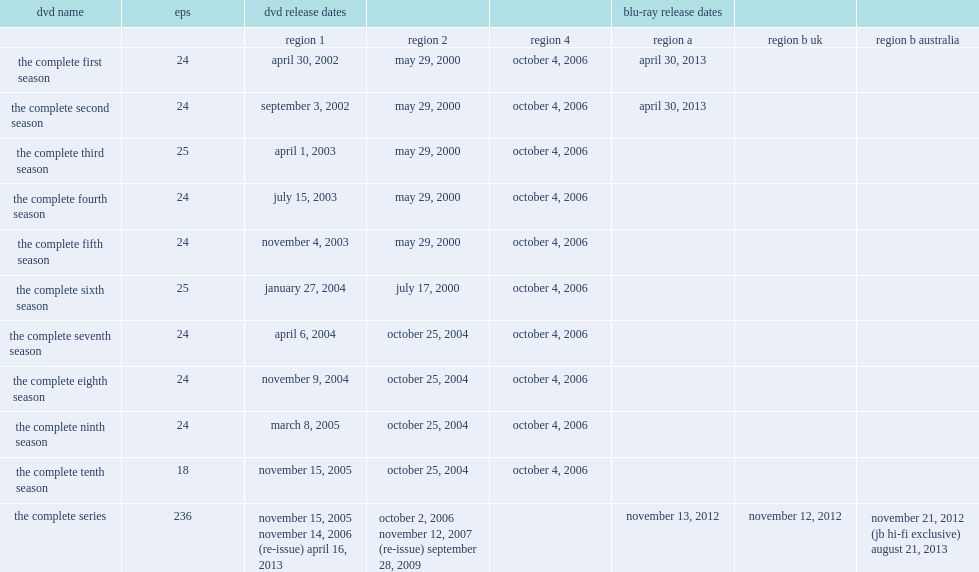How many friends episodes were available in blu-ray and dvd? 236.0. 